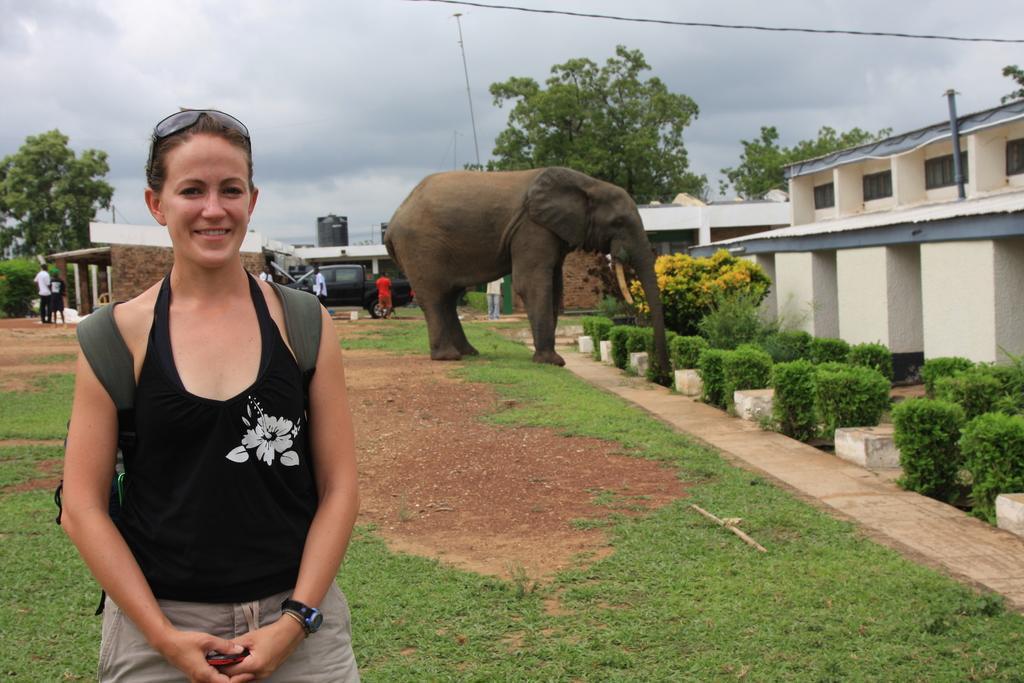Describe this image in one or two sentences. On the left side a beautiful woman is standing, she wore black color top. In the middle an elephant is standing, on the right side it looks like a house. There are trees in this image. 